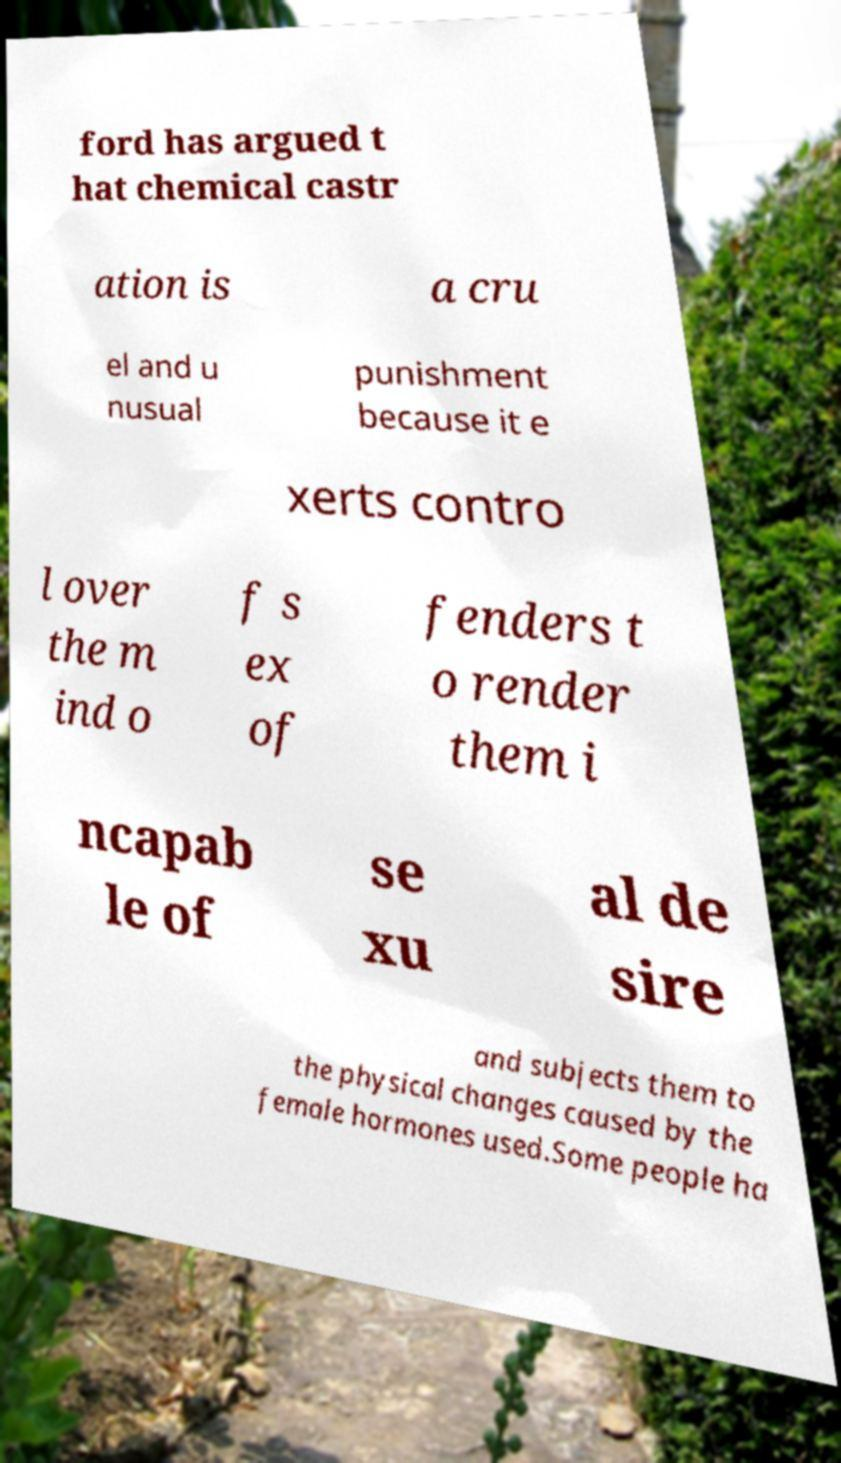Can you read and provide the text displayed in the image?This photo seems to have some interesting text. Can you extract and type it out for me? ford has argued t hat chemical castr ation is a cru el and u nusual punishment because it e xerts contro l over the m ind o f s ex of fenders t o render them i ncapab le of se xu al de sire and subjects them to the physical changes caused by the female hormones used.Some people ha 